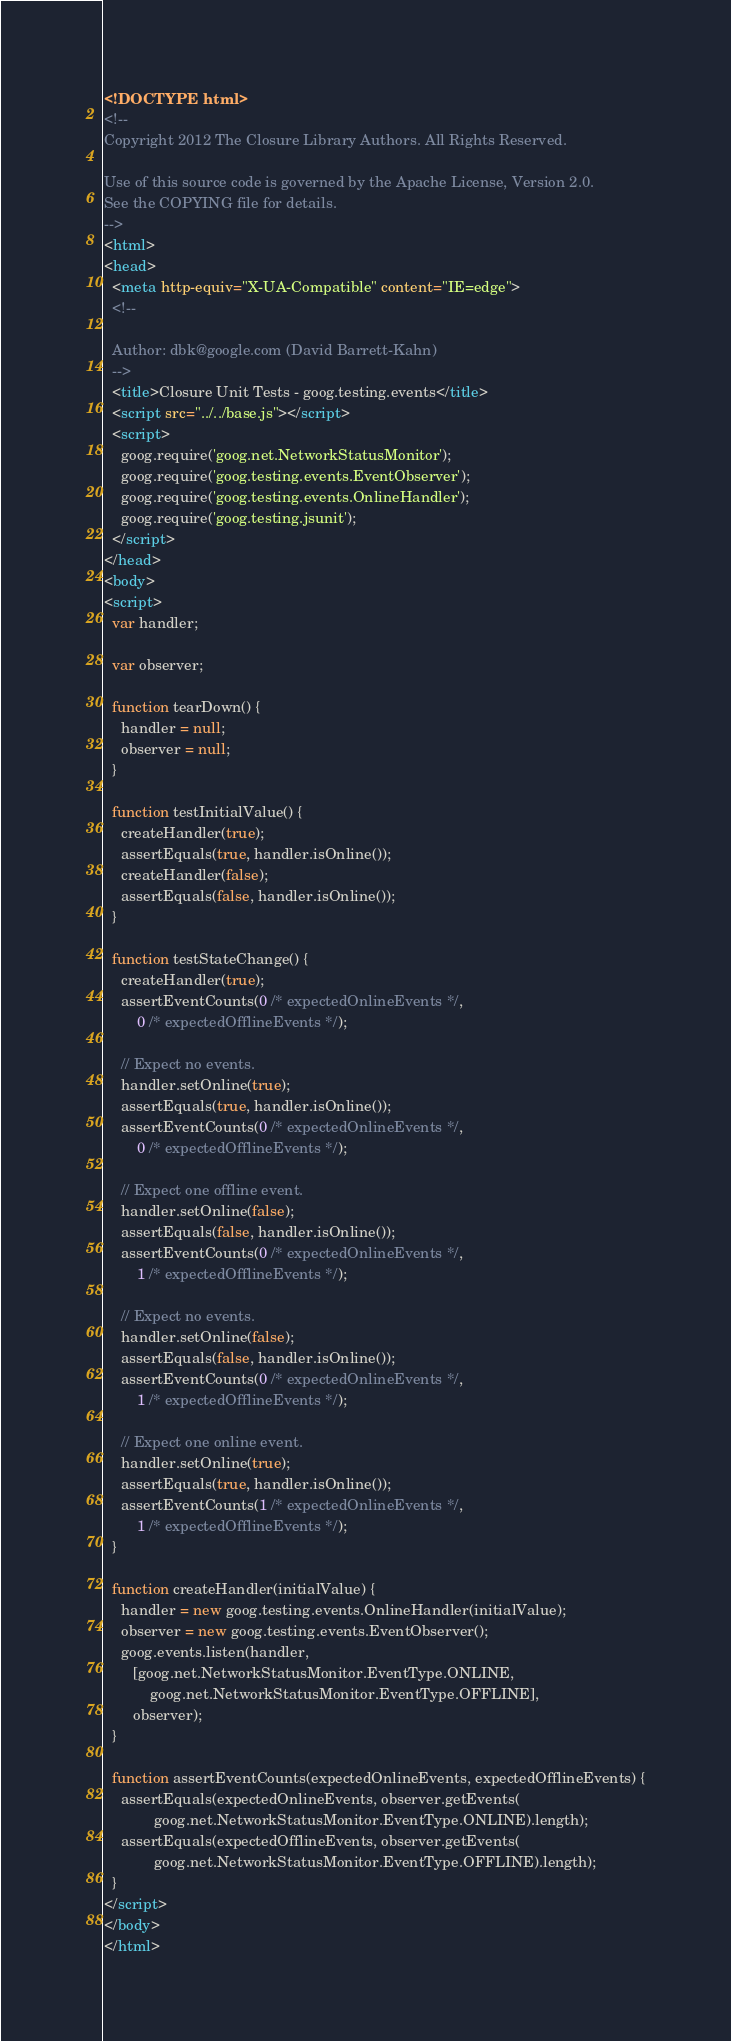Convert code to text. <code><loc_0><loc_0><loc_500><loc_500><_HTML_><!DOCTYPE html>
<!--
Copyright 2012 The Closure Library Authors. All Rights Reserved.

Use of this source code is governed by the Apache License, Version 2.0.
See the COPYING file for details.
-->
<html>
<head>
  <meta http-equiv="X-UA-Compatible" content="IE=edge">
  <!--

  Author: dbk@google.com (David Barrett-Kahn)
  -->
  <title>Closure Unit Tests - goog.testing.events</title>
  <script src="../../base.js"></script>
  <script>
    goog.require('goog.net.NetworkStatusMonitor');
    goog.require('goog.testing.events.EventObserver');
    goog.require('goog.testing.events.OnlineHandler');
    goog.require('goog.testing.jsunit');
  </script>
</head>
<body>
<script>
  var handler;

  var observer;

  function tearDown() {
    handler = null;
    observer = null;
  }

  function testInitialValue() {
    createHandler(true);
    assertEquals(true, handler.isOnline());
    createHandler(false);
    assertEquals(false, handler.isOnline());
  }

  function testStateChange() {
    createHandler(true);
    assertEventCounts(0 /* expectedOnlineEvents */,
        0 /* expectedOfflineEvents */);

    // Expect no events.
    handler.setOnline(true);
    assertEquals(true, handler.isOnline());
    assertEventCounts(0 /* expectedOnlineEvents */,
        0 /* expectedOfflineEvents */);

    // Expect one offline event.
    handler.setOnline(false);
    assertEquals(false, handler.isOnline());
    assertEventCounts(0 /* expectedOnlineEvents */,
        1 /* expectedOfflineEvents */);

    // Expect no events.
    handler.setOnline(false);
    assertEquals(false, handler.isOnline());
    assertEventCounts(0 /* expectedOnlineEvents */,
        1 /* expectedOfflineEvents */);

    // Expect one online event.
    handler.setOnline(true);
    assertEquals(true, handler.isOnline());
    assertEventCounts(1 /* expectedOnlineEvents */,
        1 /* expectedOfflineEvents */);
  }

  function createHandler(initialValue) {
    handler = new goog.testing.events.OnlineHandler(initialValue);
    observer = new goog.testing.events.EventObserver();
    goog.events.listen(handler,
       [goog.net.NetworkStatusMonitor.EventType.ONLINE,
           goog.net.NetworkStatusMonitor.EventType.OFFLINE],
       observer);
  }

  function assertEventCounts(expectedOnlineEvents, expectedOfflineEvents) {
    assertEquals(expectedOnlineEvents, observer.getEvents(
            goog.net.NetworkStatusMonitor.EventType.ONLINE).length);
    assertEquals(expectedOfflineEvents, observer.getEvents(
            goog.net.NetworkStatusMonitor.EventType.OFFLINE).length);
  }
</script>
</body>
</html>
</code> 